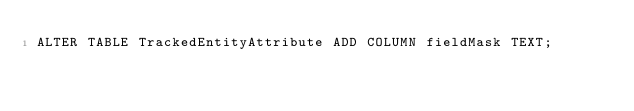Convert code to text. <code><loc_0><loc_0><loc_500><loc_500><_SQL_>ALTER TABLE TrackedEntityAttribute ADD COLUMN fieldMask TEXT;</code> 